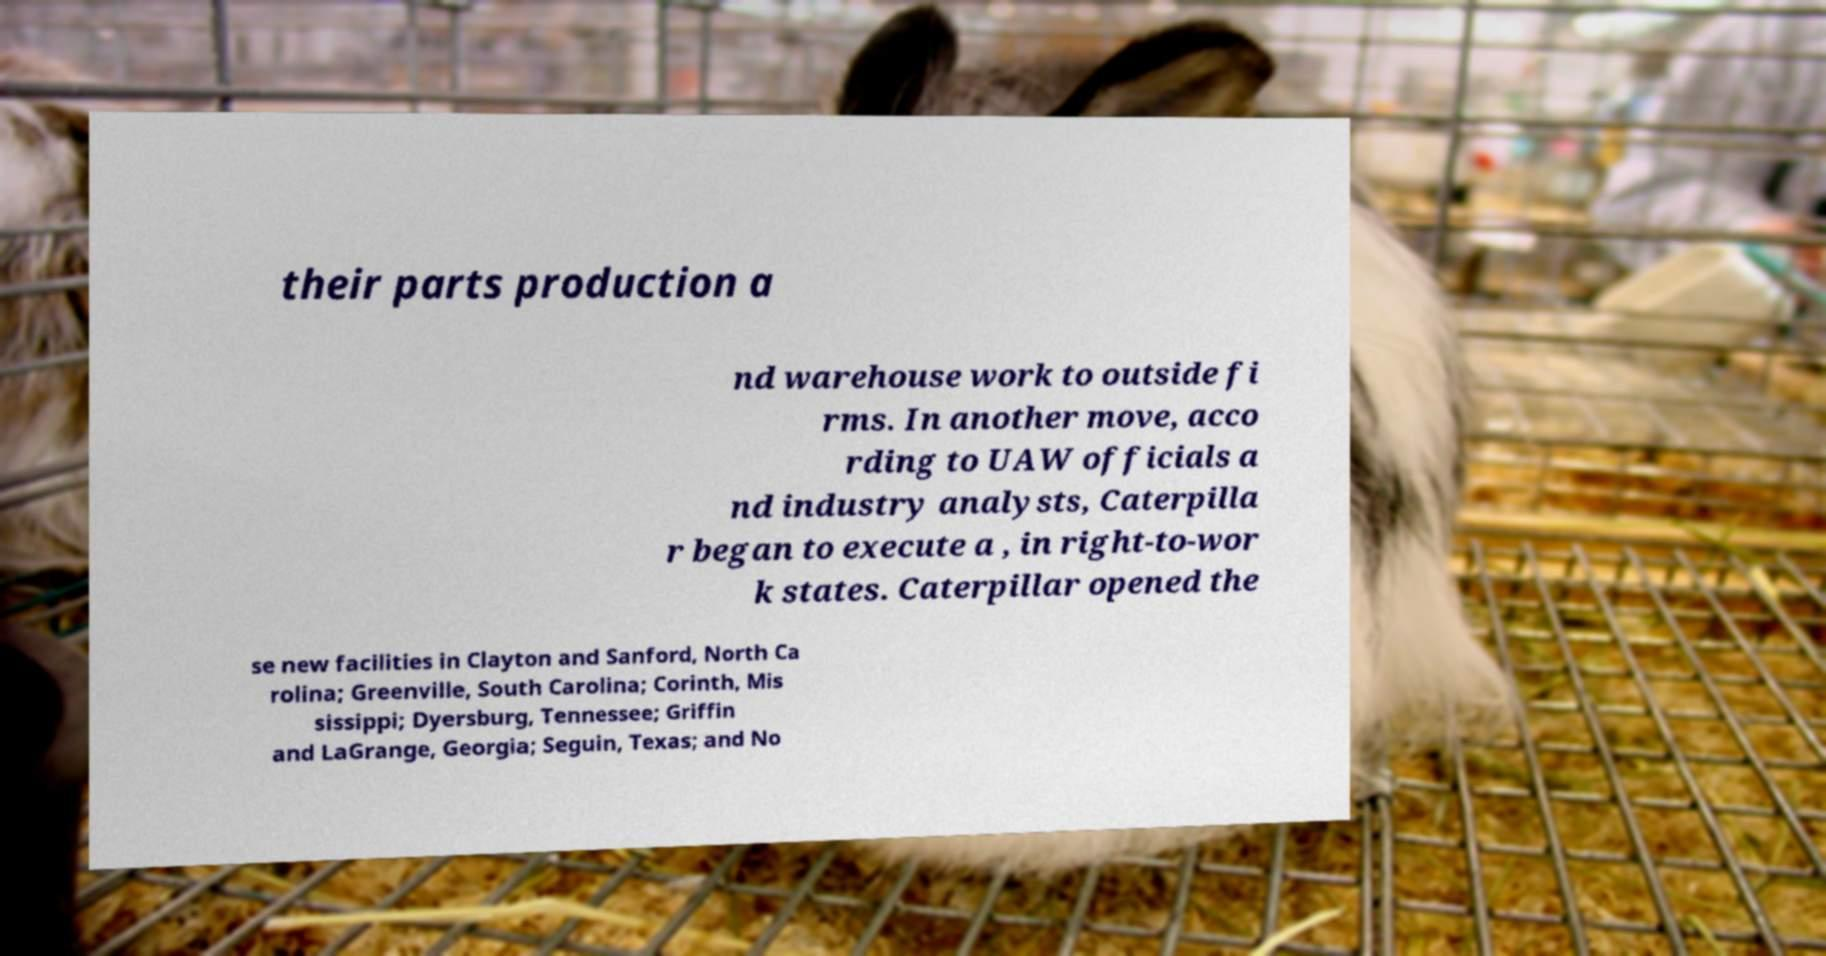I need the written content from this picture converted into text. Can you do that? their parts production a nd warehouse work to outside fi rms. In another move, acco rding to UAW officials a nd industry analysts, Caterpilla r began to execute a , in right-to-wor k states. Caterpillar opened the se new facilities in Clayton and Sanford, North Ca rolina; Greenville, South Carolina; Corinth, Mis sissippi; Dyersburg, Tennessee; Griffin and LaGrange, Georgia; Seguin, Texas; and No 